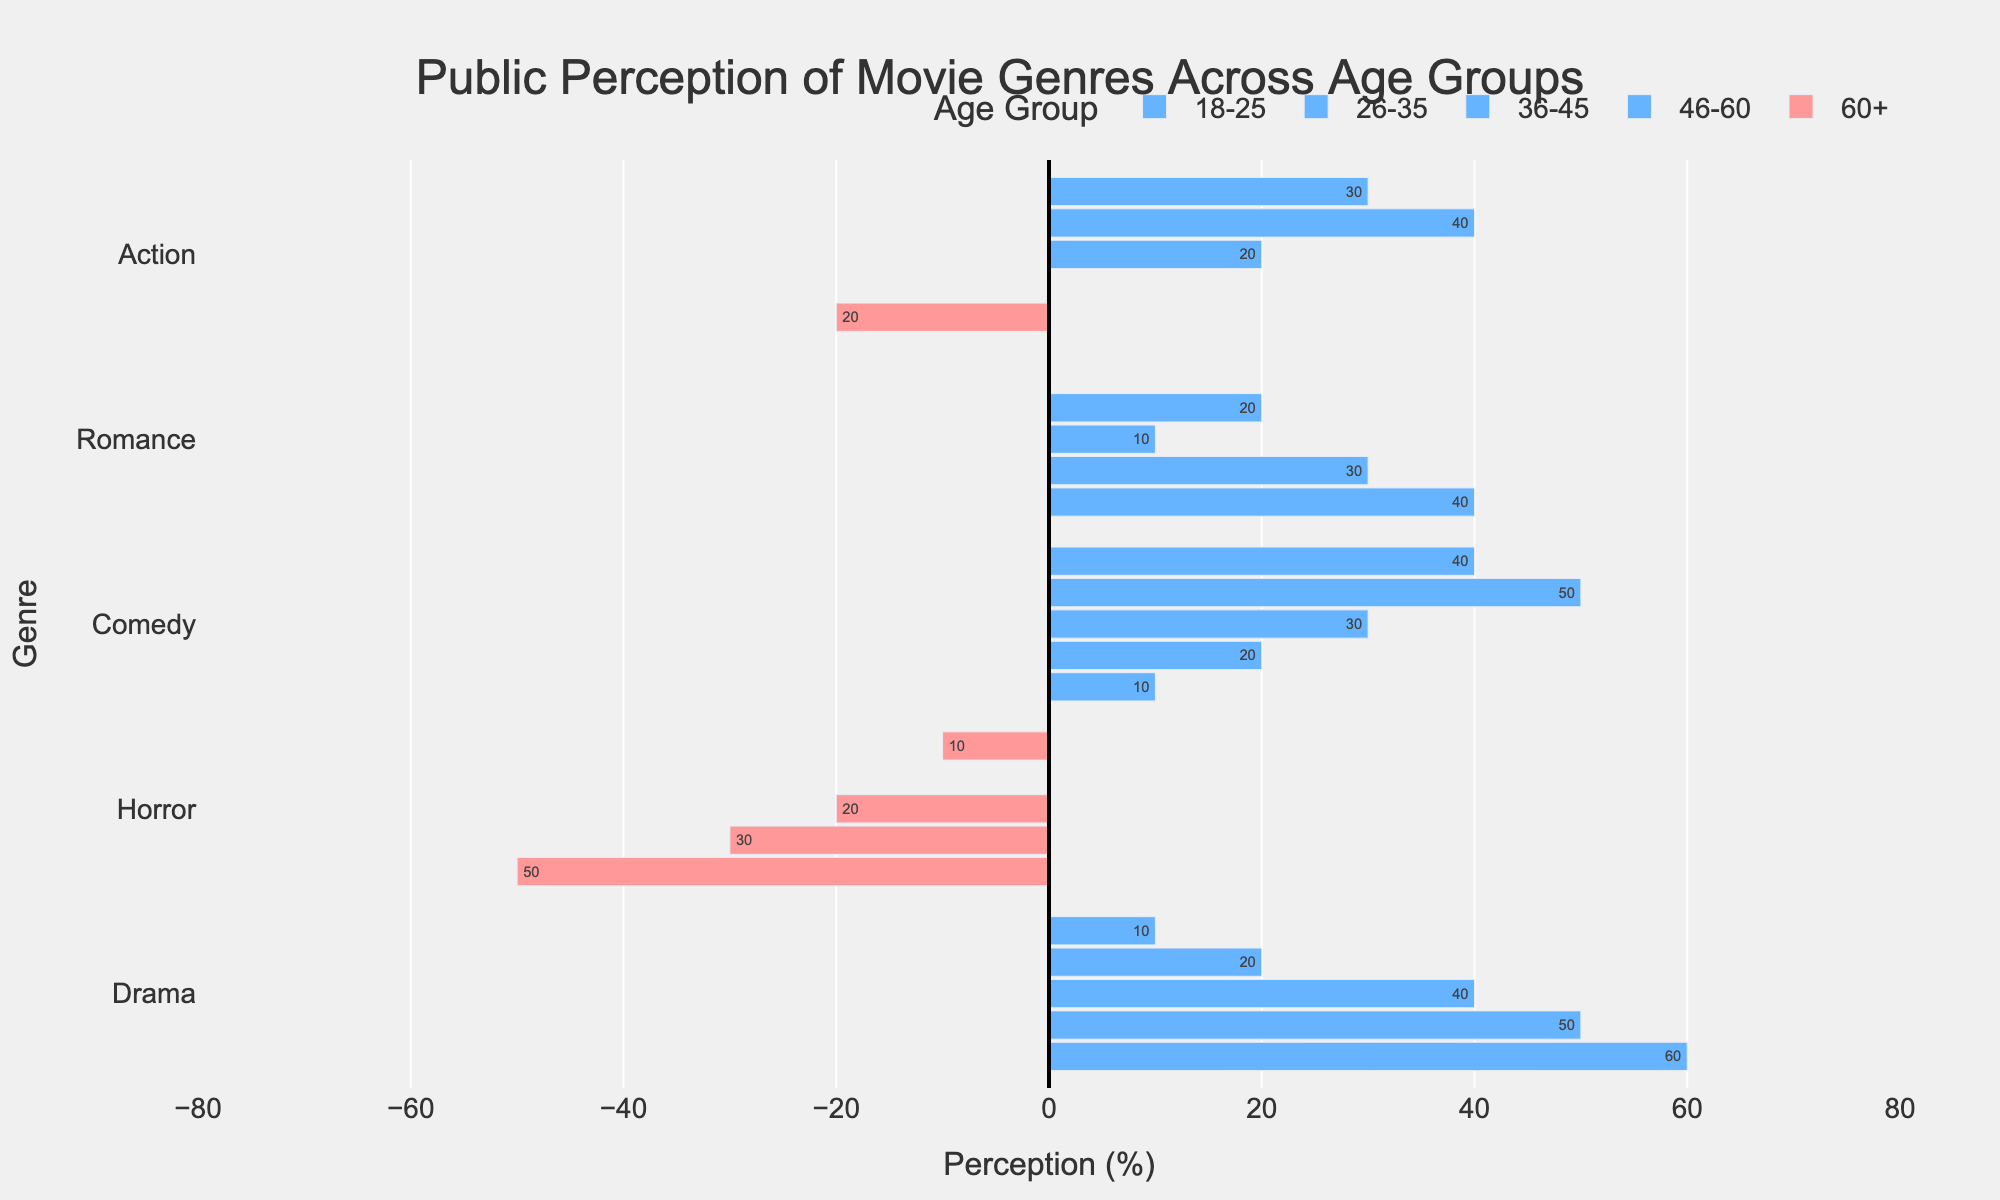What genre has the highest positive perception among age 60+? The bars for age 60+ show 80% positive perception for Drama, which is higher than other genres in that age group.
Answer: Drama Which age group has the highest negative perception of Horror movies? The age group 60+ has the bar for Horror going furthest to the negative side, indicating a -75% perception.
Answer: 60+ Compare the perception of Comedy between age groups 18-25 and 26-35. Which group has a more positive perception? The bar for Comedy is higher for the age group 26-35 at 50% compared to 40% for age group 18-25.
Answer: 26-35 What is the average positive perception of Romance among ages 26-35 and 36-45? For ages 26-35, Romance has 60% positive perception; for 36-45, it has 55%. The average is (60 + 55) / 2 = 57.5%.
Answer: 57.5% Which genre has a neutral perception (50% positive and 50% negative) across multiple age groups? The bars for Horror in age groups 18-25 and 26-35 both show 50% positive and 50% negative perception, leading to a neutral perception.
Answer: Horror What is the difference in positive perception of Action movies between age groups 18-25 and 46-60? The bar for Action in the age group 18-25 is at 65%, while it is at 50% for 46-60. The difference is 65 - 50 = 15%.
Answer: 15% Which age group shows the least negative perception for Drama movies? The bar for Drama in the age group 60+ is at -20%, which is the least negative value among all age groups for this genre.
Answer: 60+ Does any age group have an equal positive and negative perception of any genre? Yes, the bars for Romance and Horror in the age group 18-25, and the bar for Horror in the age group 26-35, show equal positive and negative perception (50%).
Answer: Yes What is the overall trend in perception of Horror movies as age increases? Observing the bars, the perception of Horror movies becomes increasingly negative with age: 18-25 (45%), 26-35 (50%), 36-45 (40%), 46-60 (35%), 60+ (25%).
Answer: More negative with age Which age group favors Romance movies the most? The bar for Romance is highest for the age group 60+, showing the highest positive perception at 70%.
Answer: 60+ 